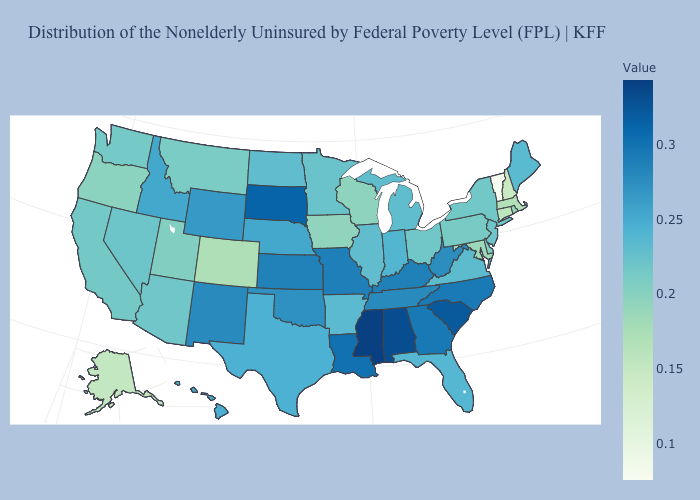Does Vermont have the lowest value in the Northeast?
Be succinct. Yes. Which states have the highest value in the USA?
Give a very brief answer. Mississippi. Does California have a lower value than Georgia?
Keep it brief. Yes. Does Nebraska have a lower value than Mississippi?
Keep it brief. Yes. Does Oklahoma have the highest value in the USA?
Keep it brief. No. Does the map have missing data?
Give a very brief answer. No. 